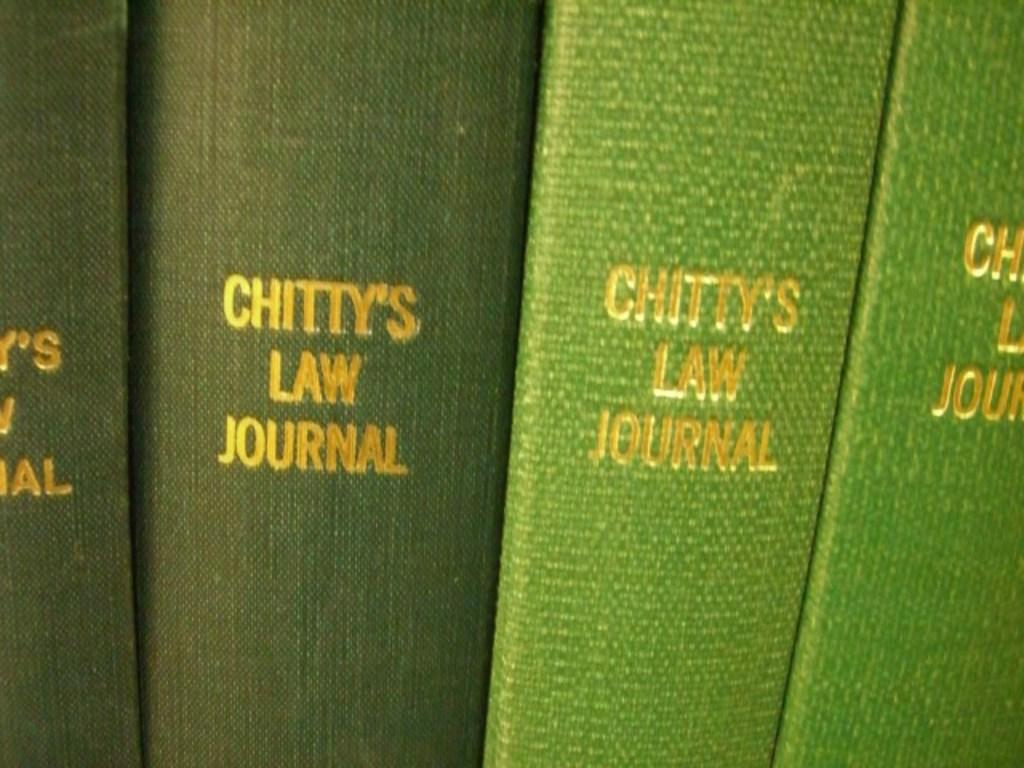<image>
Write a terse but informative summary of the picture. Four green Chitty's law journals are standing next to each other. 